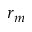Convert formula to latex. <formula><loc_0><loc_0><loc_500><loc_500>r _ { m }</formula> 